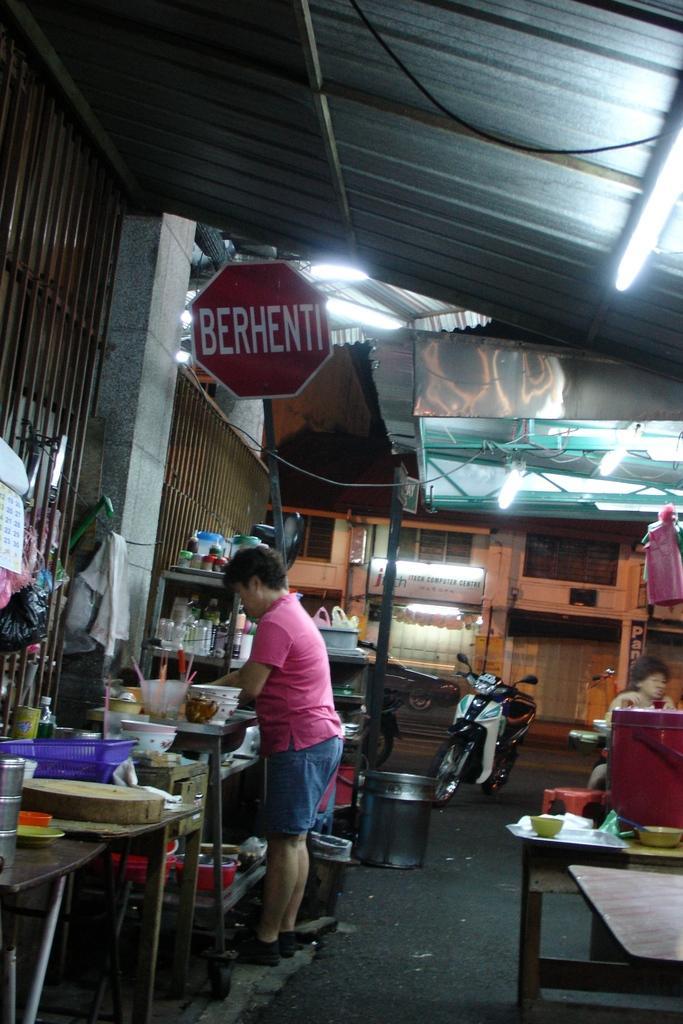Describe this image in one or two sentences. It's a street and a man is standing at here in the middle of an image there is a bike. Right side of an image there is a bike. 